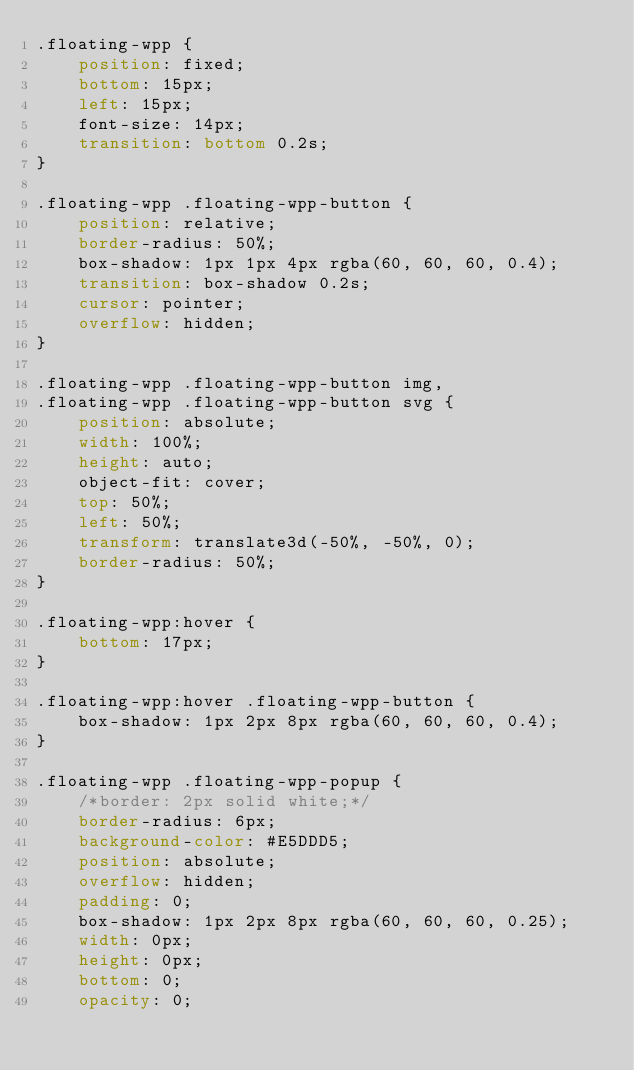<code> <loc_0><loc_0><loc_500><loc_500><_CSS_>.floating-wpp {
    position: fixed;
    bottom: 15px;
    left: 15px;
    font-size: 14px;
    transition: bottom 0.2s;
}

.floating-wpp .floating-wpp-button {
    position: relative;
    border-radius: 50%;
    box-shadow: 1px 1px 4px rgba(60, 60, 60, 0.4);
    transition: box-shadow 0.2s;
    cursor: pointer;
    overflow: hidden;
}

.floating-wpp .floating-wpp-button img,
.floating-wpp .floating-wpp-button svg {
    position: absolute;
    width: 100%;
    height: auto;
    object-fit: cover;
    top: 50%;
    left: 50%;
    transform: translate3d(-50%, -50%, 0);
    border-radius: 50%;
}

.floating-wpp:hover {
    bottom: 17px;
}

.floating-wpp:hover .floating-wpp-button {
    box-shadow: 1px 2px 8px rgba(60, 60, 60, 0.4);
}

.floating-wpp .floating-wpp-popup {
    /*border: 2px solid white;*/
    border-radius: 6px;
    background-color: #E5DDD5;
    position: absolute;
    overflow: hidden;
    padding: 0;
    box-shadow: 1px 2px 8px rgba(60, 60, 60, 0.25);
    width: 0px;
    height: 0px;
    bottom: 0;
    opacity: 0;</code> 